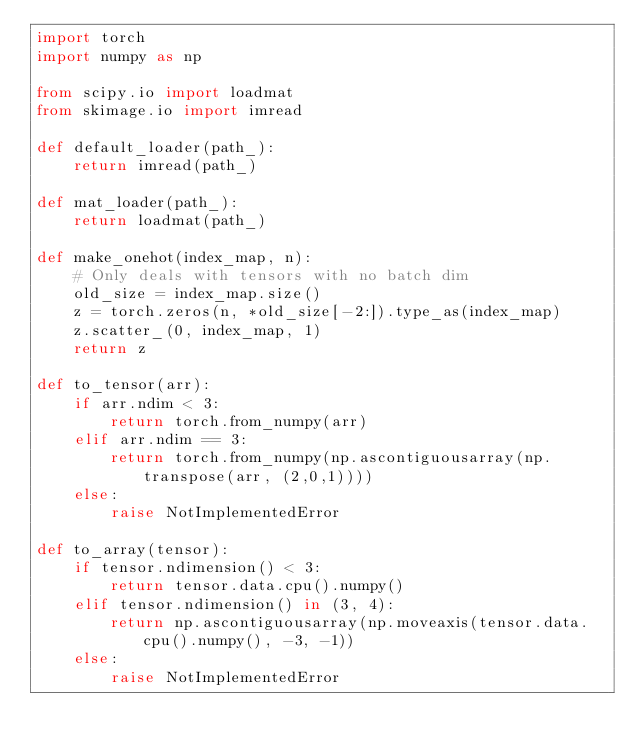<code> <loc_0><loc_0><loc_500><loc_500><_Python_>import torch
import numpy as np

from scipy.io import loadmat
from skimage.io import imread

def default_loader(path_):
    return imread(path_)

def mat_loader(path_):
    return loadmat(path_)

def make_onehot(index_map, n):
    # Only deals with tensors with no batch dim
    old_size = index_map.size()
    z = torch.zeros(n, *old_size[-2:]).type_as(index_map)
    z.scatter_(0, index_map, 1)
    return z
    
def to_tensor(arr):
    if arr.ndim < 3:
        return torch.from_numpy(arr)
    elif arr.ndim == 3:
        return torch.from_numpy(np.ascontiguousarray(np.transpose(arr, (2,0,1))))
    else:
        raise NotImplementedError

def to_array(tensor):
    if tensor.ndimension() < 3:
        return tensor.data.cpu().numpy()
    elif tensor.ndimension() in (3, 4):
        return np.ascontiguousarray(np.moveaxis(tensor.data.cpu().numpy(), -3, -1))
    else:
        raise NotImplementedError</code> 